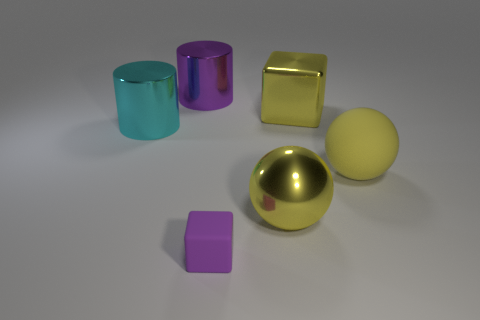Subtract 1 cylinders. How many cylinders are left? 1 Add 4 big yellow blocks. How many objects exist? 10 Subtract all balls. How many objects are left? 4 Subtract all big purple cylinders. Subtract all small purple rubber blocks. How many objects are left? 4 Add 1 big purple objects. How many big purple objects are left? 2 Add 2 big gray metallic balls. How many big gray metallic balls exist? 2 Subtract all yellow blocks. How many blocks are left? 1 Subtract 0 brown cylinders. How many objects are left? 6 Subtract all brown cylinders. Subtract all green balls. How many cylinders are left? 2 Subtract all gray balls. How many blue cubes are left? 0 